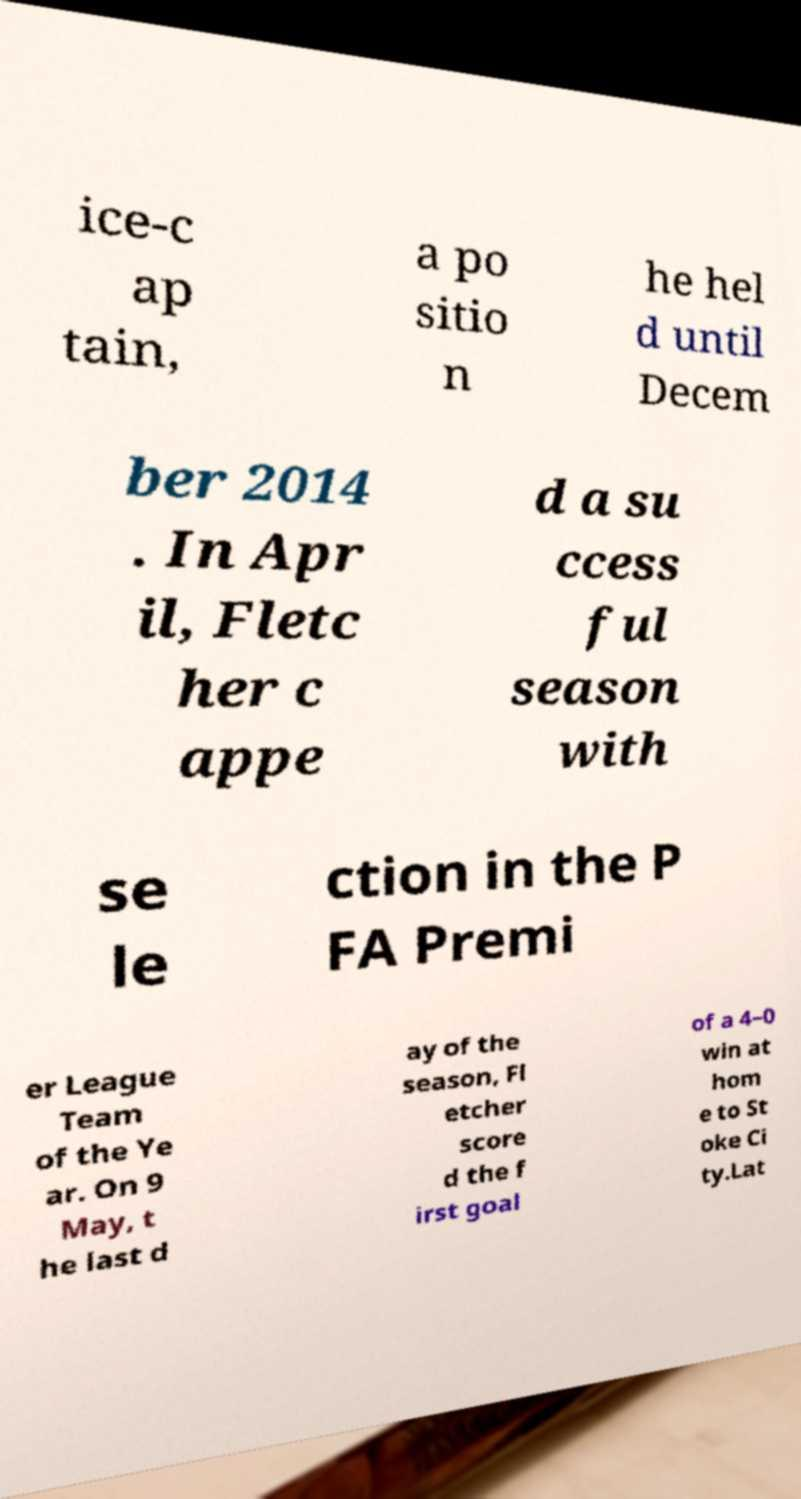Could you assist in decoding the text presented in this image and type it out clearly? ice-c ap tain, a po sitio n he hel d until Decem ber 2014 . In Apr il, Fletc her c appe d a su ccess ful season with se le ction in the P FA Premi er League Team of the Ye ar. On 9 May, t he last d ay of the season, Fl etcher score d the f irst goal of a 4–0 win at hom e to St oke Ci ty.Lat 